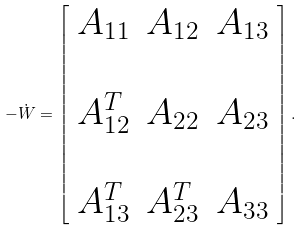<formula> <loc_0><loc_0><loc_500><loc_500>- \dot { W } = \left [ \begin{array} { c c c } A _ { 1 1 } & A _ { 1 2 } & A _ { 1 3 } \\ \\ A _ { 1 2 } ^ { T } & A _ { 2 2 } & A _ { 2 3 } \\ \\ A _ { 1 3 } ^ { T } & A _ { 2 3 } ^ { T } & A _ { 3 3 } \end{array} \right ] .</formula> 